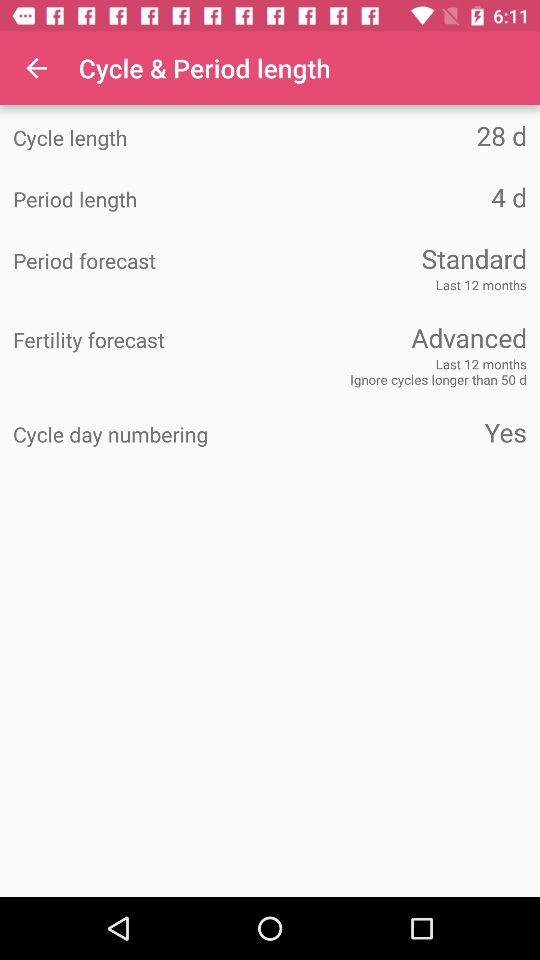What is the cycle length of the period? The cycle length of the period is 28 days. 